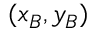Convert formula to latex. <formula><loc_0><loc_0><loc_500><loc_500>( x _ { B } , y _ { B } )</formula> 